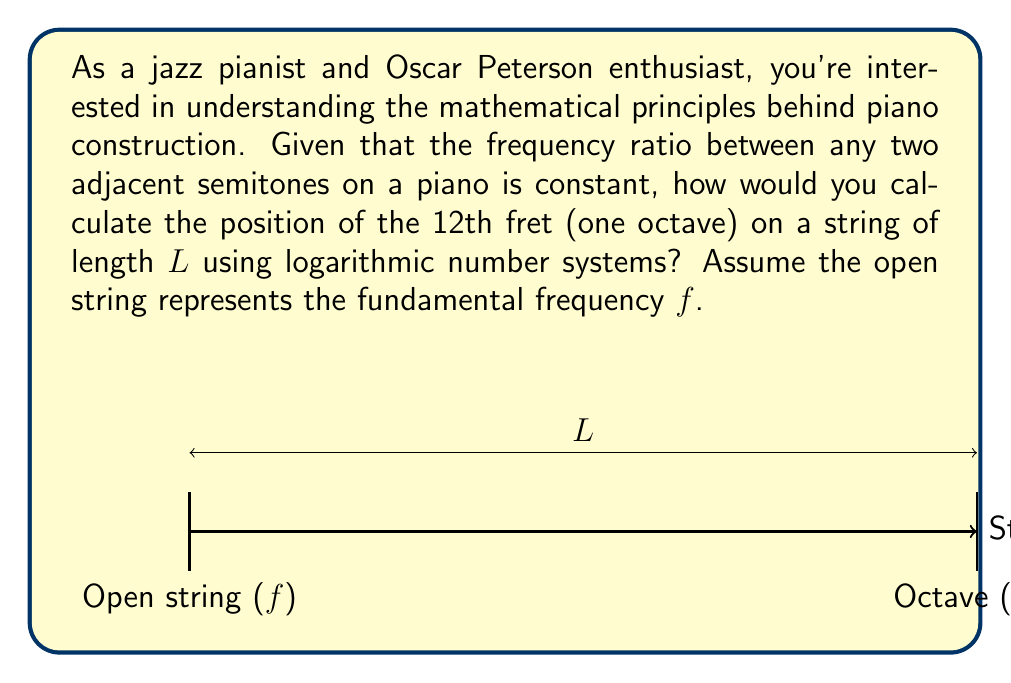Could you help me with this problem? To solve this problem, we'll use the properties of logarithms and the relationship between frequency and string length. Let's approach this step-by-step:

1) In an equally tempered scale, the frequency ratio between any two adjacent semitones is constant. This ratio is the 12th root of 2, as there are 12 semitones in an octave:

   $$r = \sqrt[12]{2} \approx 1.059463$$

2) The frequency of the 12th fret (one octave higher) is twice the fundamental frequency:

   $$f_{12} = 2f$$

3) The relationship between frequency and string length is inverse. If we call the length of the string at the 12th fret x, we can write:

   $$\frac{f_{12}}{f} = \frac{L}{x}$$

4) Substituting what we know:

   $$2 = \frac{L}{x}$$

5) Solving for x:

   $$x = \frac{L}{2}$$

6) Now, let's approach this using logarithms. The position of each fret can be calculated using the formula:

   $$x_n = L(1 - \frac{1}{r^n})$$

   Where n is the fret number, and r is the frequency ratio between adjacent frets.

7) For the 12th fret (n = 12), we can write:

   $$x_{12} = L(1 - \frac{1}{(\sqrt[12]{2})^{12}})$$

8) Simplify:

   $$x_{12} = L(1 - \frac{1}{2}) = \frac{L}{2}$$

This logarithmic approach confirms our earlier result.
Answer: $$x = \frac{L}{2}$$ 